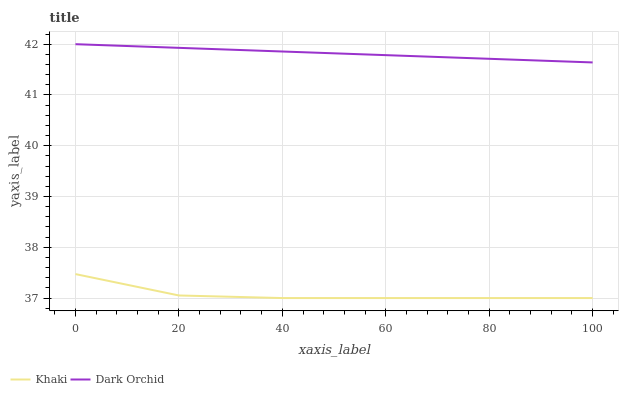Does Khaki have the minimum area under the curve?
Answer yes or no. Yes. Does Dark Orchid have the maximum area under the curve?
Answer yes or no. Yes. Does Dark Orchid have the minimum area under the curve?
Answer yes or no. No. Is Dark Orchid the smoothest?
Answer yes or no. Yes. Is Khaki the roughest?
Answer yes or no. Yes. Is Dark Orchid the roughest?
Answer yes or no. No. Does Khaki have the lowest value?
Answer yes or no. Yes. Does Dark Orchid have the lowest value?
Answer yes or no. No. Does Dark Orchid have the highest value?
Answer yes or no. Yes. Is Khaki less than Dark Orchid?
Answer yes or no. Yes. Is Dark Orchid greater than Khaki?
Answer yes or no. Yes. Does Khaki intersect Dark Orchid?
Answer yes or no. No. 